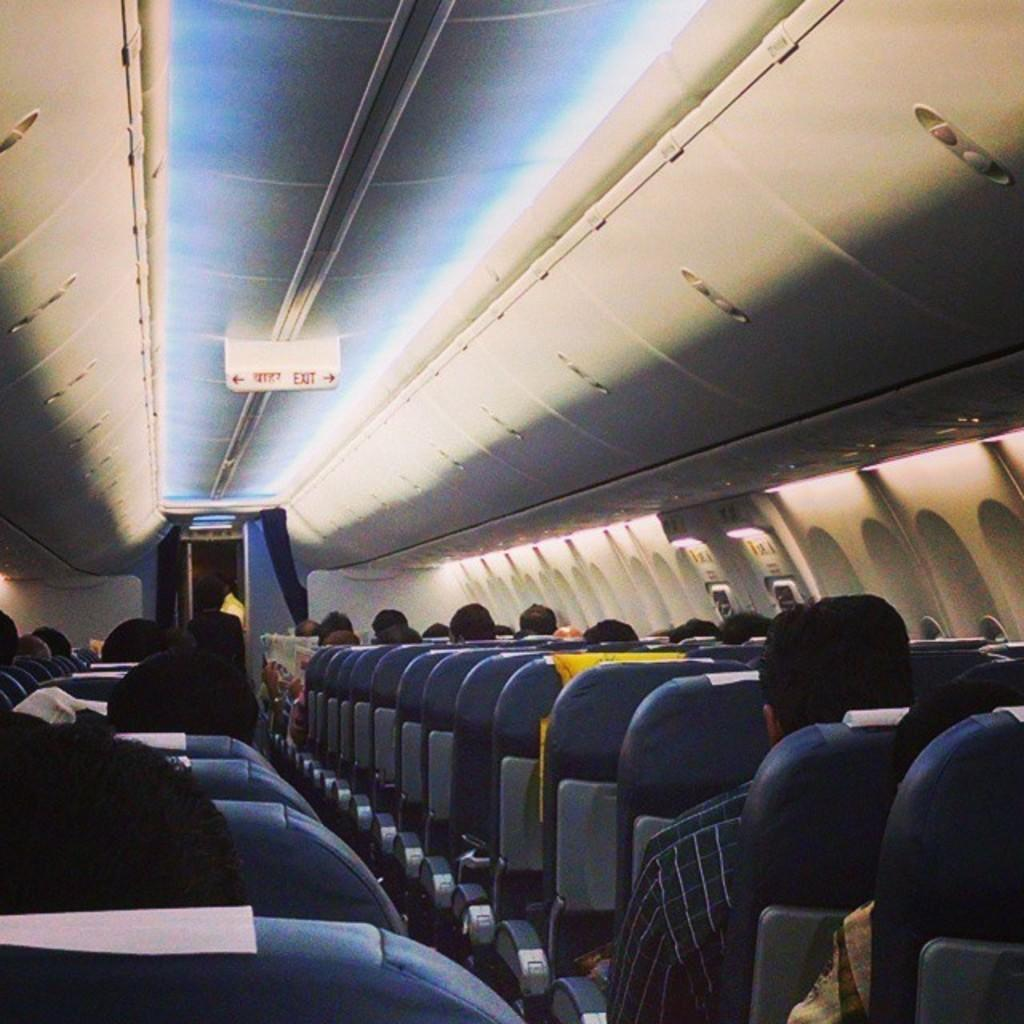<image>
Write a terse but informative summary of the picture. Some passengers are seated on an aircraft with arrows and exit signs on the ceiling above them. 